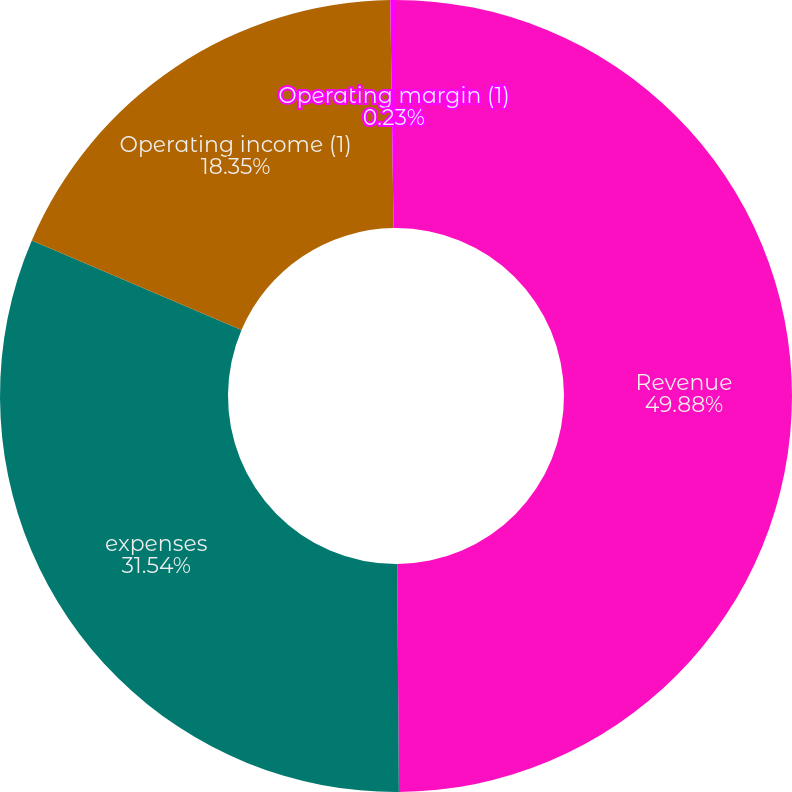Convert chart. <chart><loc_0><loc_0><loc_500><loc_500><pie_chart><fcel>Revenue<fcel>expenses<fcel>Operating income (1)<fcel>Operating margin (1)<nl><fcel>49.89%<fcel>31.54%<fcel>18.35%<fcel>0.23%<nl></chart> 